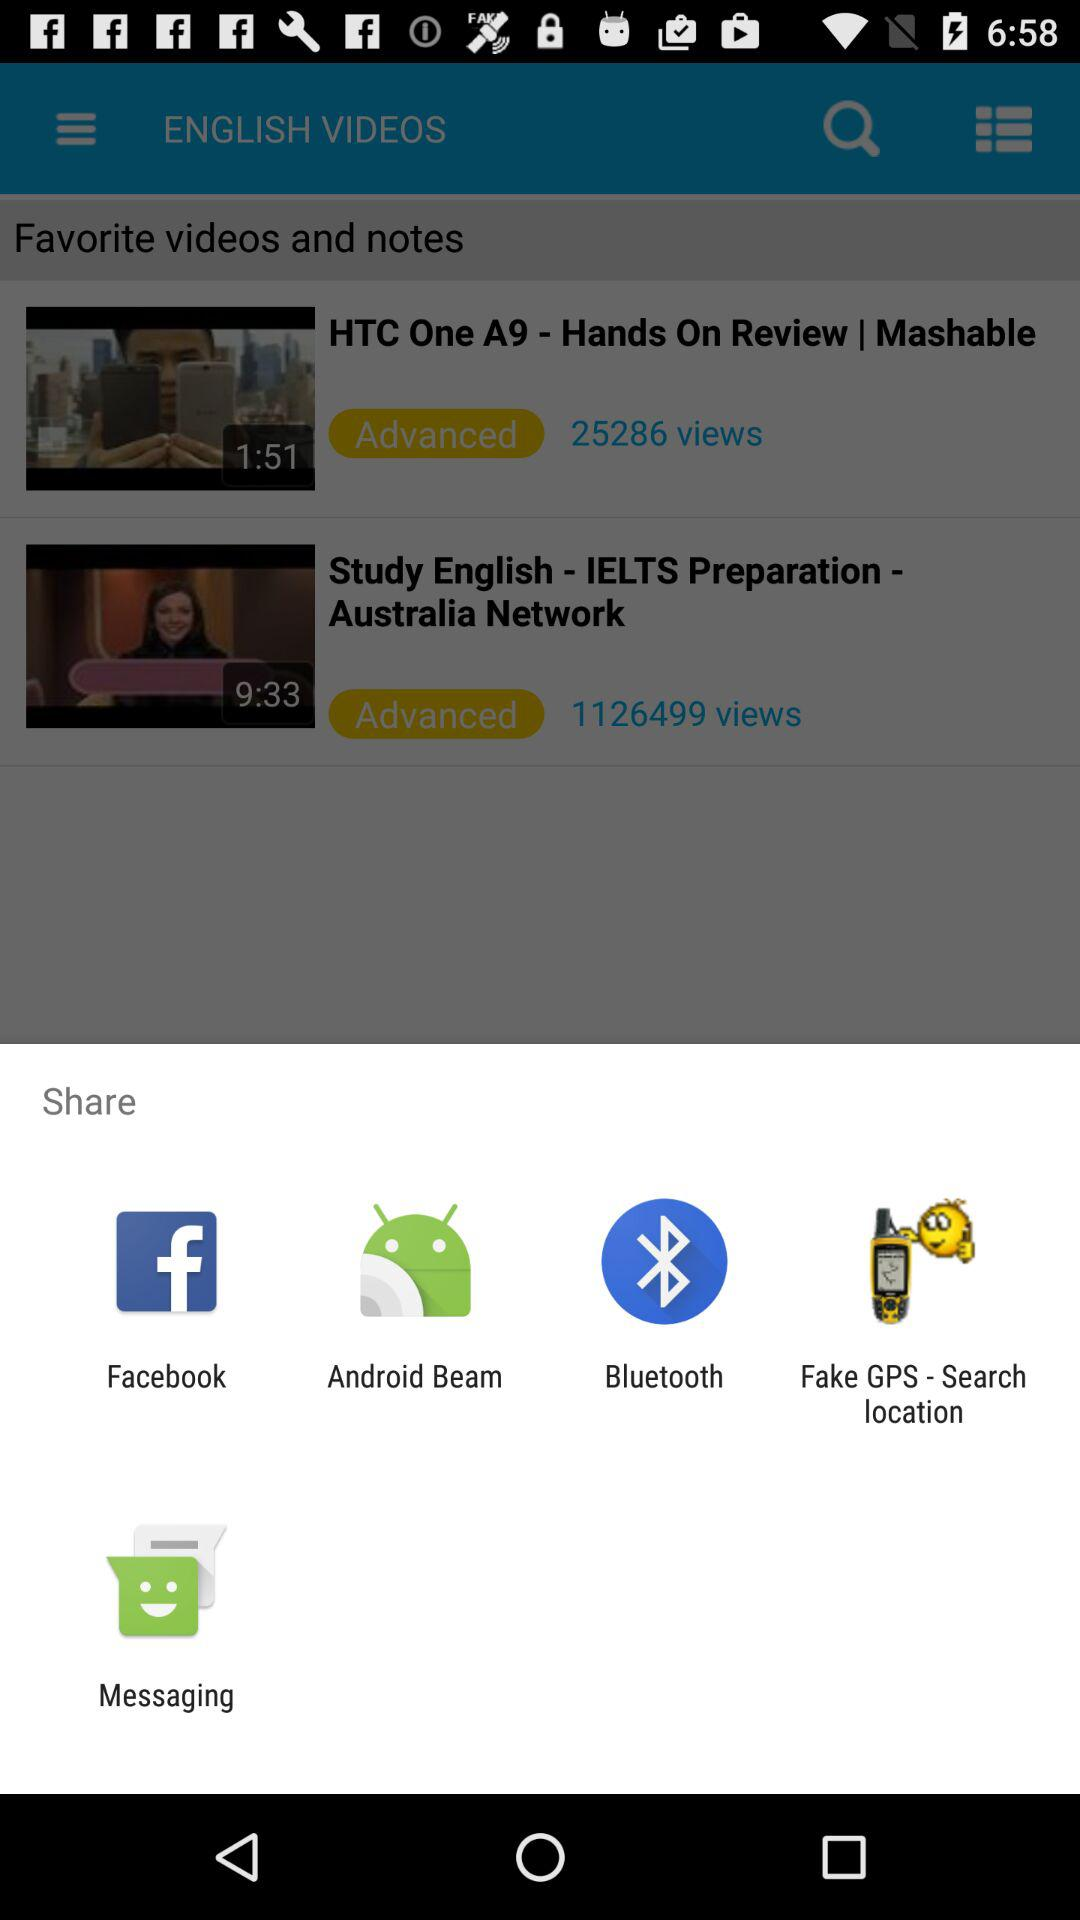Which are the various available sharing options? The various available sharing options are "Facebook", "Android Beam", "Bluetooth", "Fake GPS - Search location" and "Messaging". 